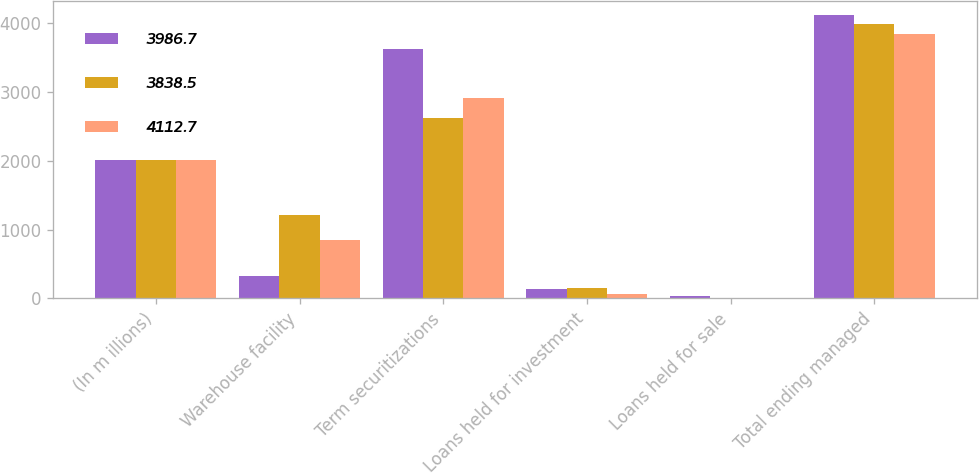Convert chart. <chart><loc_0><loc_0><loc_500><loc_500><stacked_bar_chart><ecel><fcel>(In m illions)<fcel>Warehouse facility<fcel>Term securitizations<fcel>Loans held for investment<fcel>Loans held for sale<fcel>Total ending managed<nl><fcel>3986.7<fcel>2010<fcel>331<fcel>3615.6<fcel>135.5<fcel>30.6<fcel>4112.7<nl><fcel>3838.5<fcel>2009<fcel>1215<fcel>2616.9<fcel>145.1<fcel>9.7<fcel>3986.7<nl><fcel>4112.7<fcel>2008<fcel>854.5<fcel>2910<fcel>69<fcel>5<fcel>3838.5<nl></chart> 